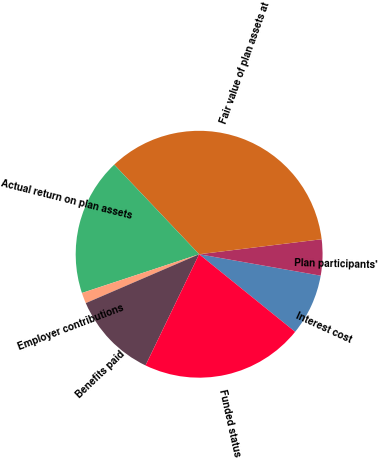Convert chart to OTSL. <chart><loc_0><loc_0><loc_500><loc_500><pie_chart><fcel>Interest cost<fcel>Plan participants'<fcel>Fair value of plan assets at<fcel>Actual return on plan assets<fcel>Employer contributions<fcel>Benefits paid<fcel>Funded status<nl><fcel>8.04%<fcel>4.72%<fcel>35.13%<fcel>18.01%<fcel>1.4%<fcel>11.37%<fcel>21.33%<nl></chart> 